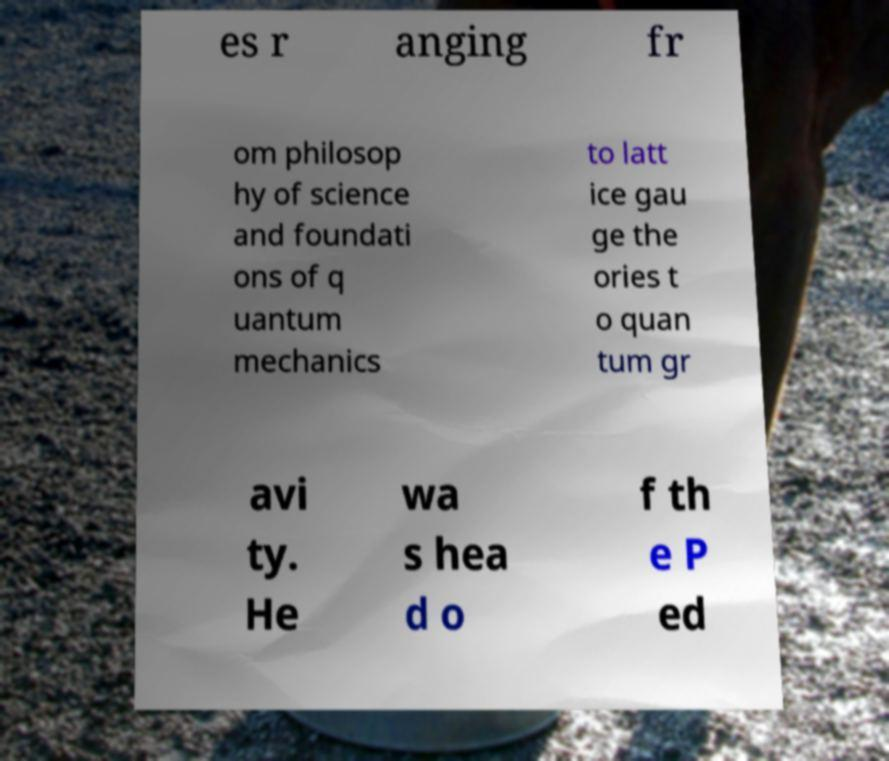Please identify and transcribe the text found in this image. es r anging fr om philosop hy of science and foundati ons of q uantum mechanics to latt ice gau ge the ories t o quan tum gr avi ty. He wa s hea d o f th e P ed 